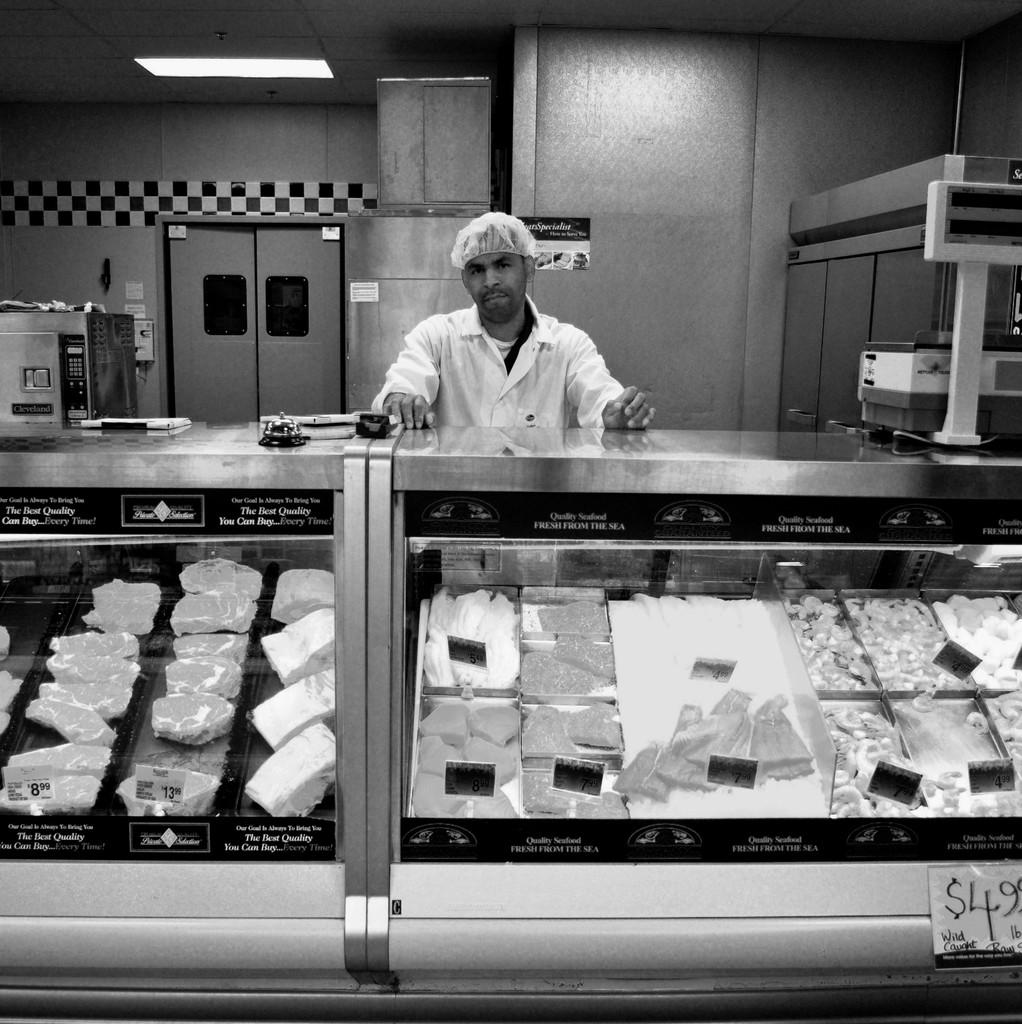What is the price on sale at the bottom right?
Provide a succinct answer. $4.99. What whole dollar amount is the price on the bottom right closest to?
Your response must be concise. 5. 